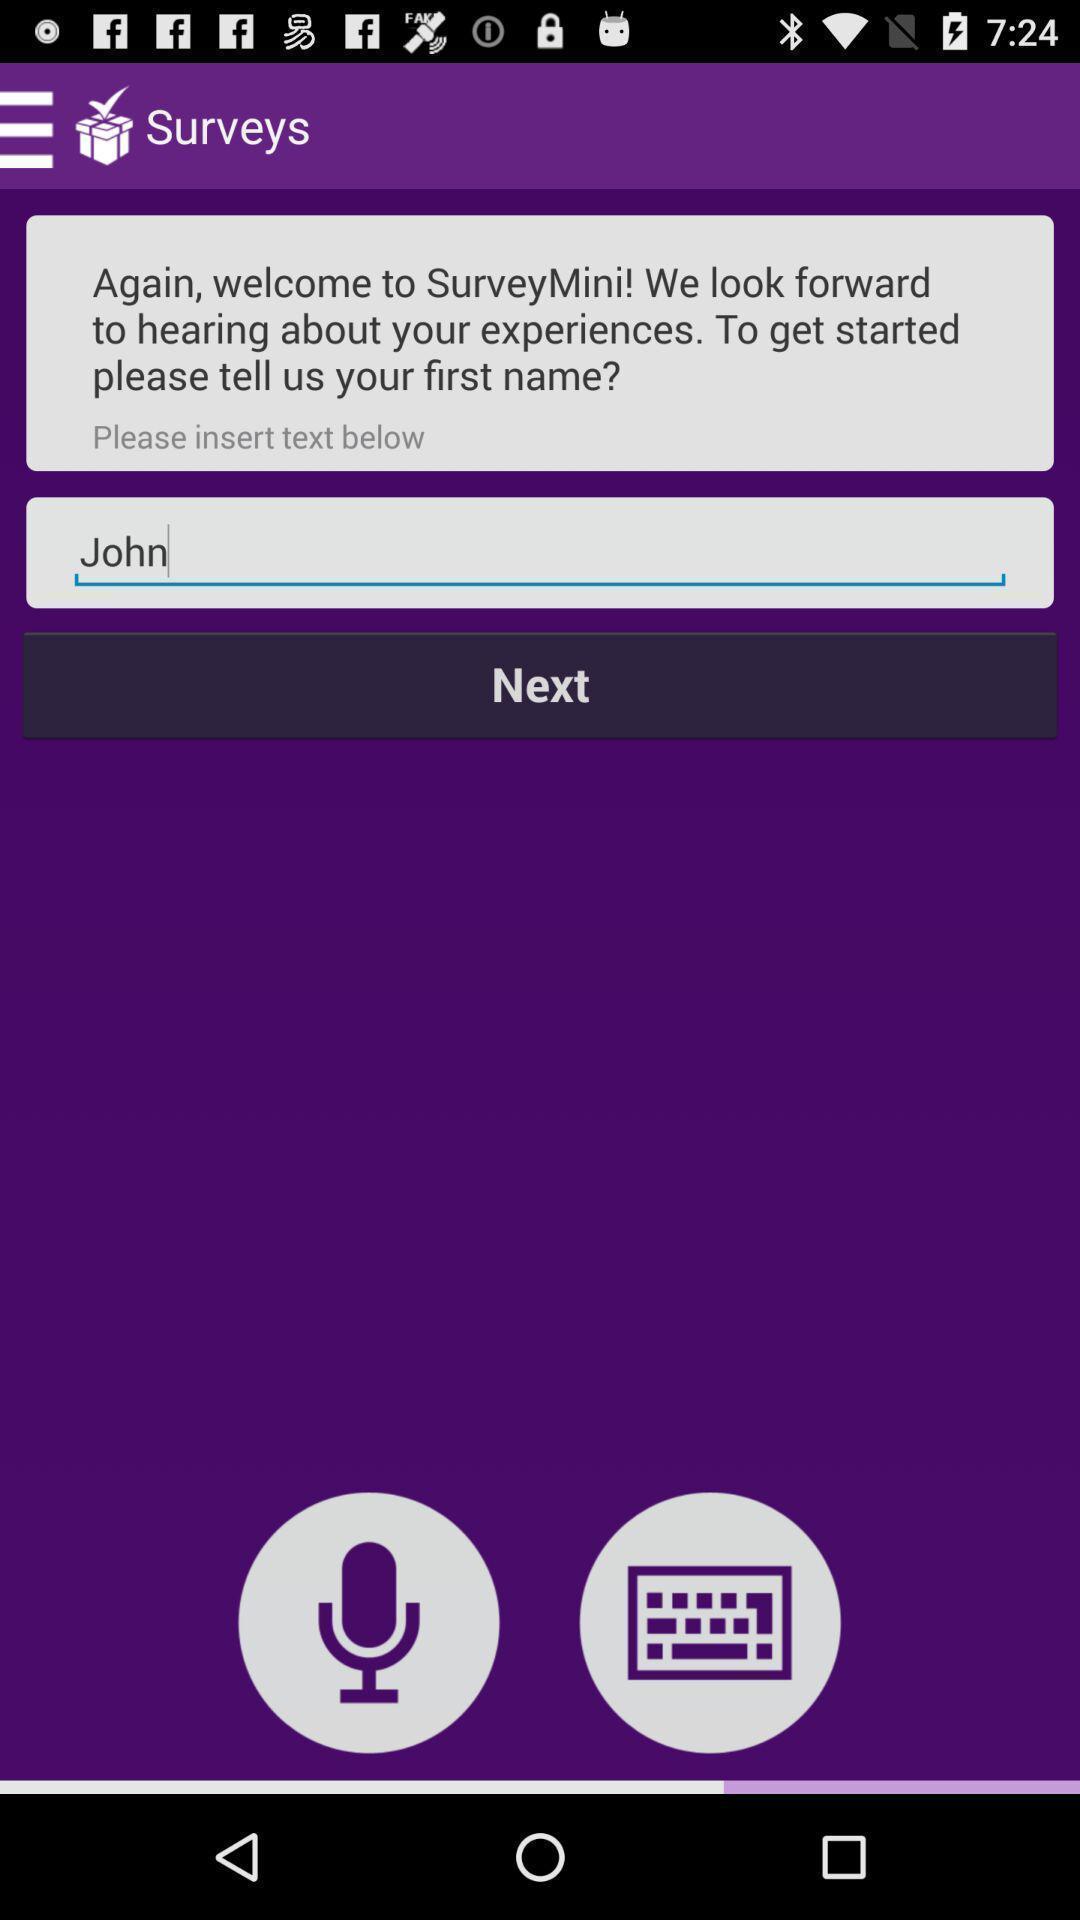Give me a narrative description of this picture. Welcome page. 